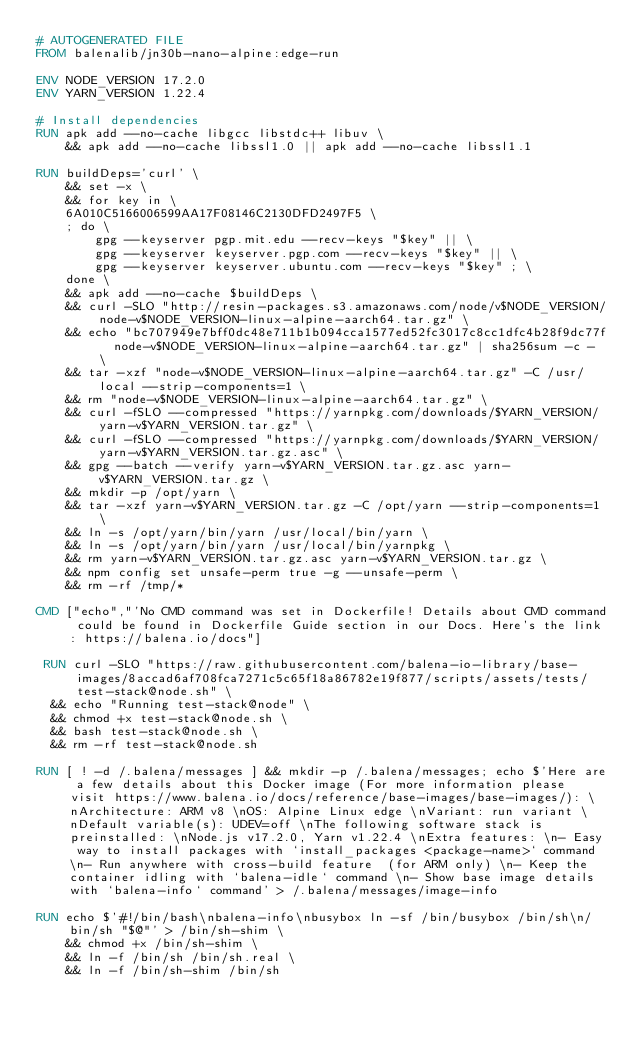<code> <loc_0><loc_0><loc_500><loc_500><_Dockerfile_># AUTOGENERATED FILE
FROM balenalib/jn30b-nano-alpine:edge-run

ENV NODE_VERSION 17.2.0
ENV YARN_VERSION 1.22.4

# Install dependencies
RUN apk add --no-cache libgcc libstdc++ libuv \
	&& apk add --no-cache libssl1.0 || apk add --no-cache libssl1.1

RUN buildDeps='curl' \
	&& set -x \
	&& for key in \
	6A010C5166006599AA17F08146C2130DFD2497F5 \
	; do \
		gpg --keyserver pgp.mit.edu --recv-keys "$key" || \
		gpg --keyserver keyserver.pgp.com --recv-keys "$key" || \
		gpg --keyserver keyserver.ubuntu.com --recv-keys "$key" ; \
	done \
	&& apk add --no-cache $buildDeps \
	&& curl -SLO "http://resin-packages.s3.amazonaws.com/node/v$NODE_VERSION/node-v$NODE_VERSION-linux-alpine-aarch64.tar.gz" \
	&& echo "bc707949e7bff0dc48e711b1b094cca1577ed52fc3017c8cc1dfc4b28f9dc77f  node-v$NODE_VERSION-linux-alpine-aarch64.tar.gz" | sha256sum -c - \
	&& tar -xzf "node-v$NODE_VERSION-linux-alpine-aarch64.tar.gz" -C /usr/local --strip-components=1 \
	&& rm "node-v$NODE_VERSION-linux-alpine-aarch64.tar.gz" \
	&& curl -fSLO --compressed "https://yarnpkg.com/downloads/$YARN_VERSION/yarn-v$YARN_VERSION.tar.gz" \
	&& curl -fSLO --compressed "https://yarnpkg.com/downloads/$YARN_VERSION/yarn-v$YARN_VERSION.tar.gz.asc" \
	&& gpg --batch --verify yarn-v$YARN_VERSION.tar.gz.asc yarn-v$YARN_VERSION.tar.gz \
	&& mkdir -p /opt/yarn \
	&& tar -xzf yarn-v$YARN_VERSION.tar.gz -C /opt/yarn --strip-components=1 \
	&& ln -s /opt/yarn/bin/yarn /usr/local/bin/yarn \
	&& ln -s /opt/yarn/bin/yarn /usr/local/bin/yarnpkg \
	&& rm yarn-v$YARN_VERSION.tar.gz.asc yarn-v$YARN_VERSION.tar.gz \
	&& npm config set unsafe-perm true -g --unsafe-perm \
	&& rm -rf /tmp/*

CMD ["echo","'No CMD command was set in Dockerfile! Details about CMD command could be found in Dockerfile Guide section in our Docs. Here's the link: https://balena.io/docs"]

 RUN curl -SLO "https://raw.githubusercontent.com/balena-io-library/base-images/8accad6af708fca7271c5c65f18a86782e19f877/scripts/assets/tests/test-stack@node.sh" \
  && echo "Running test-stack@node" \
  && chmod +x test-stack@node.sh \
  && bash test-stack@node.sh \
  && rm -rf test-stack@node.sh 

RUN [ ! -d /.balena/messages ] && mkdir -p /.balena/messages; echo $'Here are a few details about this Docker image (For more information please visit https://www.balena.io/docs/reference/base-images/base-images/): \nArchitecture: ARM v8 \nOS: Alpine Linux edge \nVariant: run variant \nDefault variable(s): UDEV=off \nThe following software stack is preinstalled: \nNode.js v17.2.0, Yarn v1.22.4 \nExtra features: \n- Easy way to install packages with `install_packages <package-name>` command \n- Run anywhere with cross-build feature  (for ARM only) \n- Keep the container idling with `balena-idle` command \n- Show base image details with `balena-info` command' > /.balena/messages/image-info

RUN echo $'#!/bin/bash\nbalena-info\nbusybox ln -sf /bin/busybox /bin/sh\n/bin/sh "$@"' > /bin/sh-shim \
	&& chmod +x /bin/sh-shim \
	&& ln -f /bin/sh /bin/sh.real \
	&& ln -f /bin/sh-shim /bin/sh</code> 